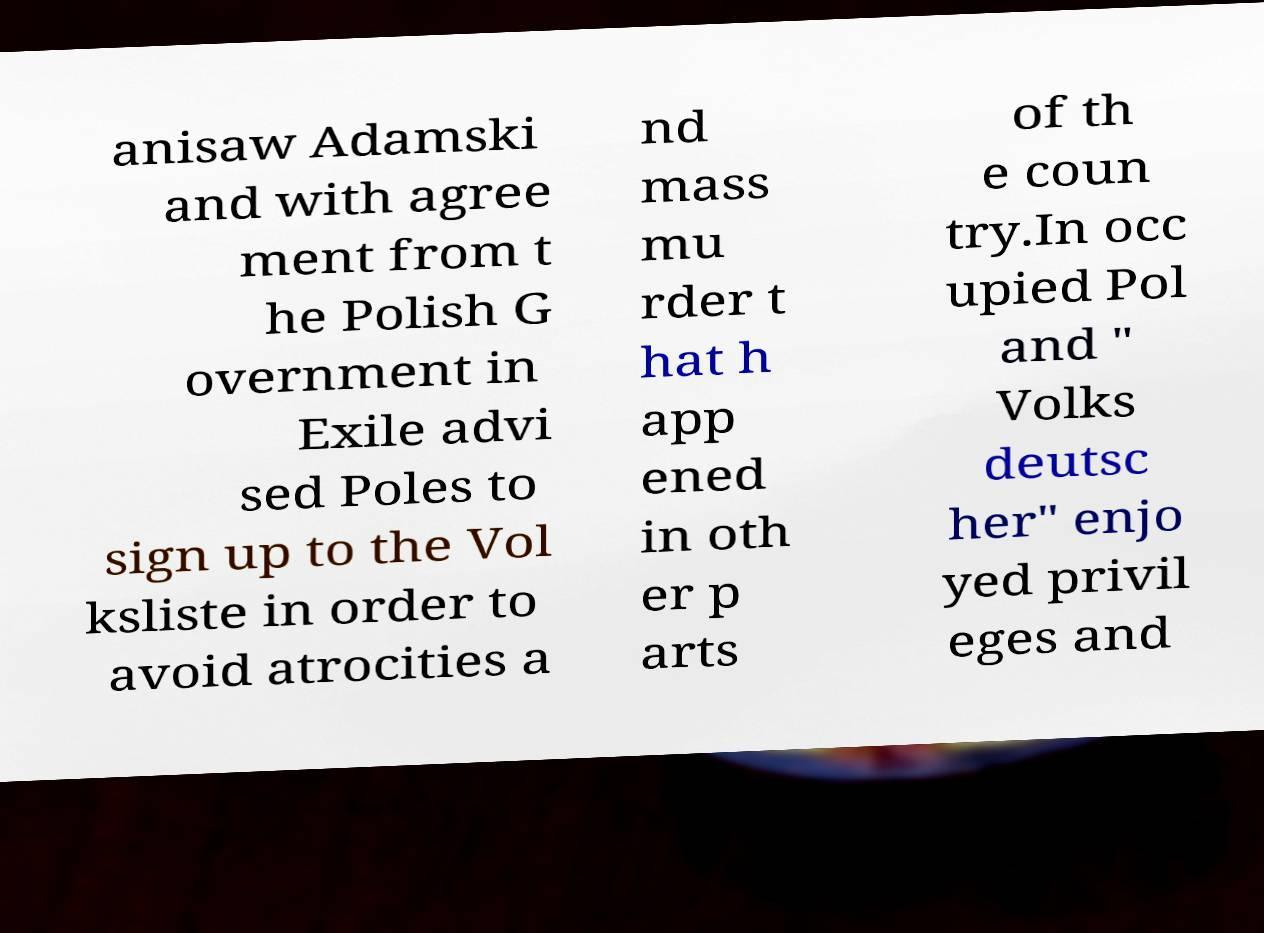Please identify and transcribe the text found in this image. anisaw Adamski and with agree ment from t he Polish G overnment in Exile advi sed Poles to sign up to the Vol ksliste in order to avoid atrocities a nd mass mu rder t hat h app ened in oth er p arts of th e coun try.In occ upied Pol and " Volks deutsc her" enjo yed privil eges and 